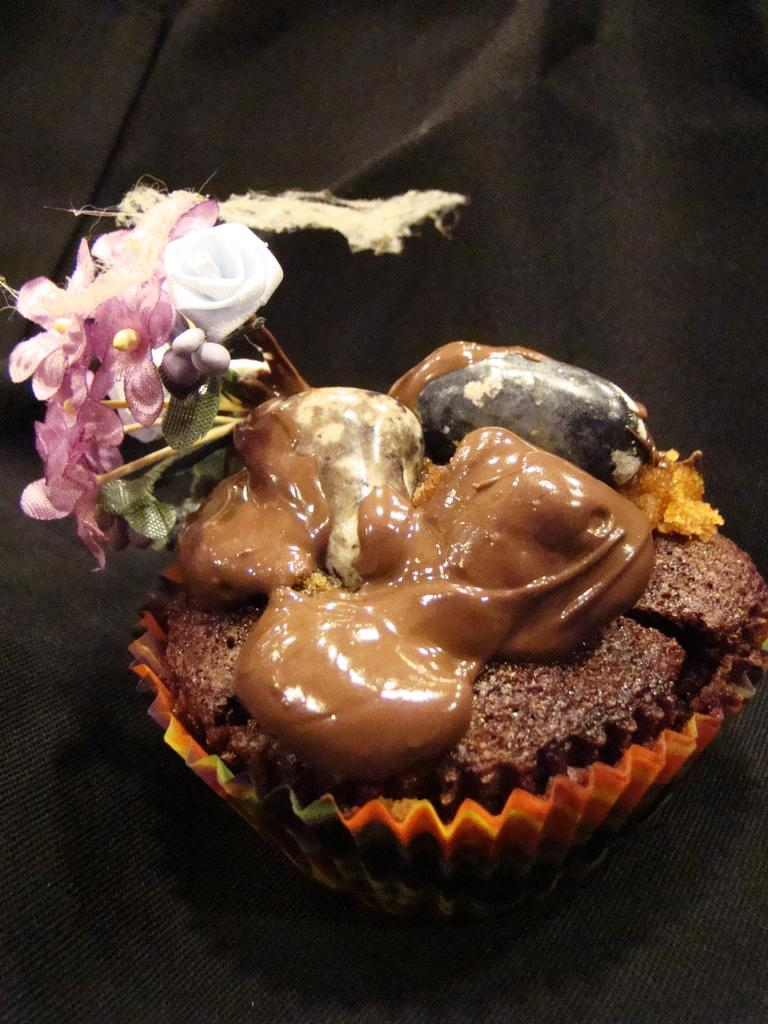What can be seen in the image? There is an object in the image. What is the color of the surface on which the object is placed? The object is placed on a black surface. What type of mailbox does the daughter use in the image? There is no mailbox or daughter present in the image; only an object on a black surface is visible. 